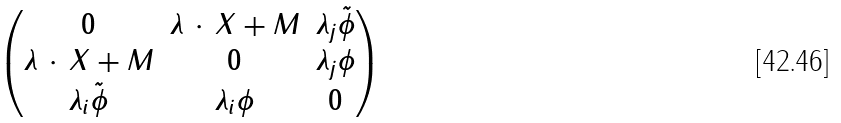<formula> <loc_0><loc_0><loc_500><loc_500>\begin{pmatrix} 0 & \lambda \, \cdot \, X + M & \lambda _ { j } { \tilde { \phi } } \\ \lambda \, \cdot \, X + M & 0 & \lambda _ { j } \phi \\ \lambda _ { i } { \tilde { \phi } } & \lambda _ { i } \phi & 0 \end{pmatrix}</formula> 